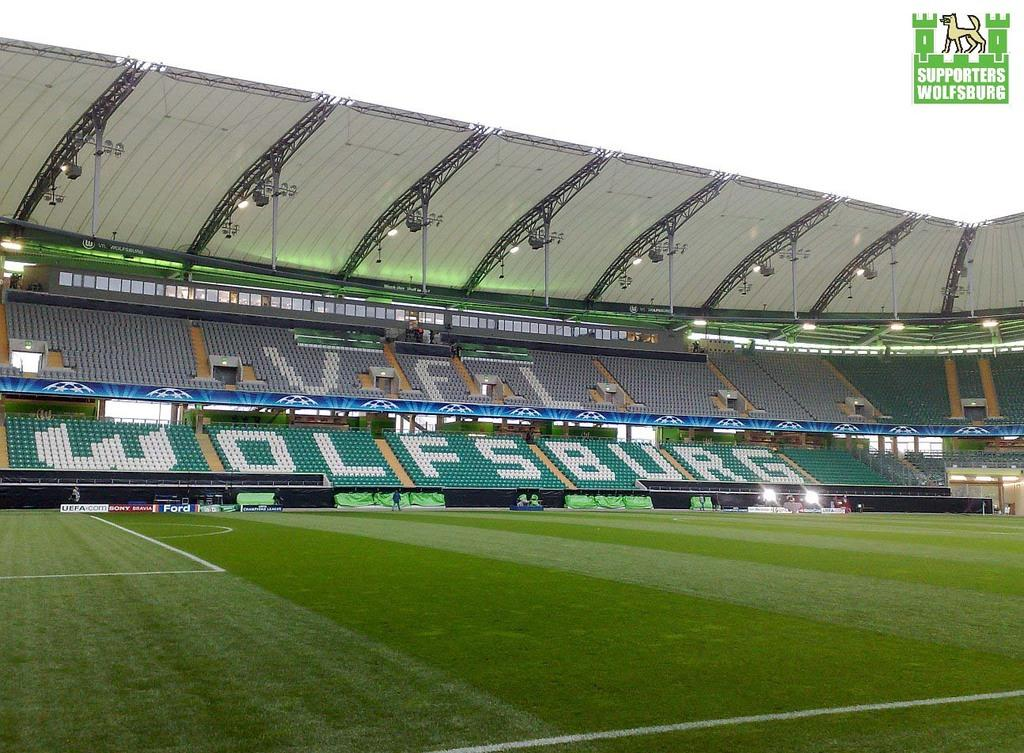<image>
Share a concise interpretation of the image provided. A fieldside photograph of the VFL Wolfsburg soccer stadium. 